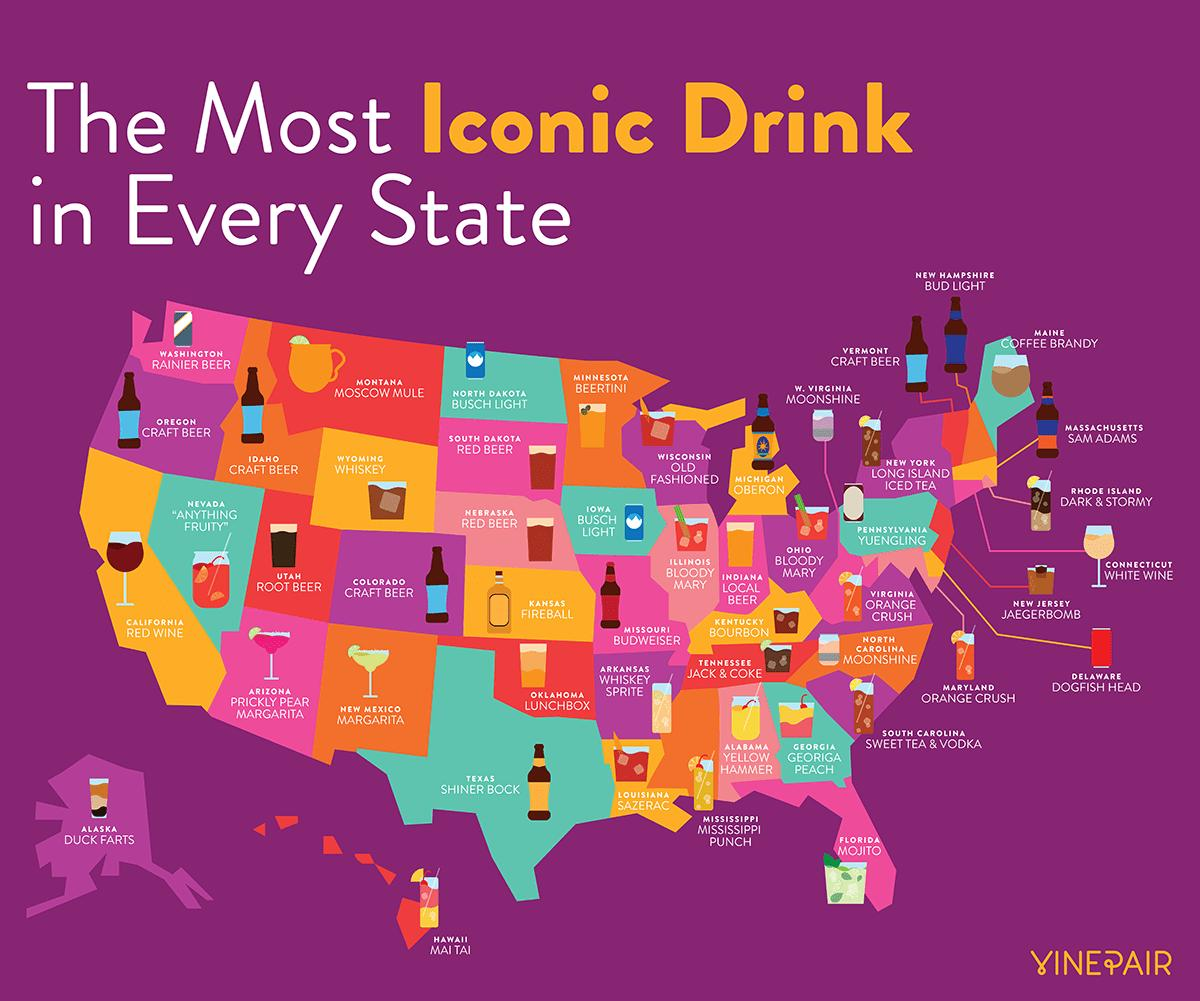Draw attention to some important aspects in this diagram. Four states are known for craft beer as their iconic drink. Busch Light is the iconic drink in North Dakota and Iowa. 